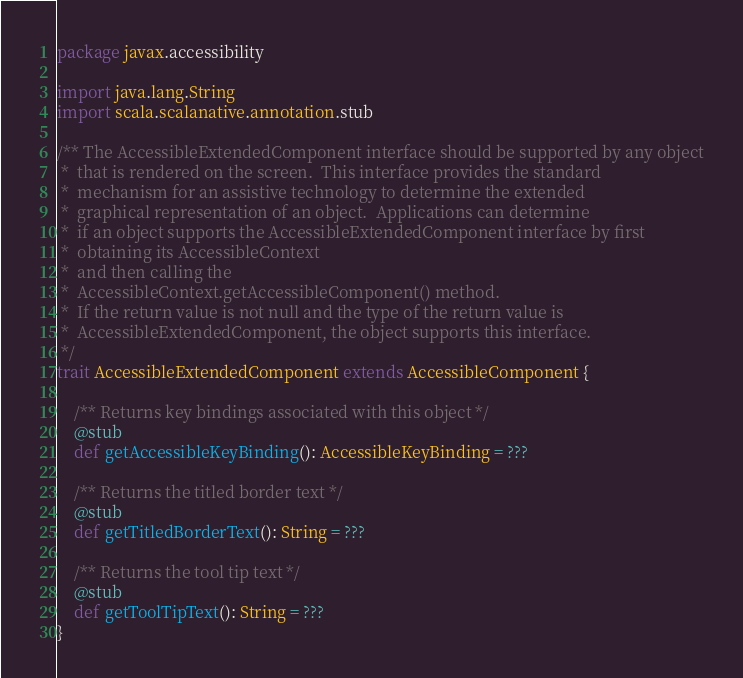<code> <loc_0><loc_0><loc_500><loc_500><_Scala_>package javax.accessibility

import java.lang.String
import scala.scalanative.annotation.stub

/** The AccessibleExtendedComponent interface should be supported by any object
 *  that is rendered on the screen.  This interface provides the standard
 *  mechanism for an assistive technology to determine the extended
 *  graphical representation of an object.  Applications can determine
 *  if an object supports the AccessibleExtendedComponent interface by first
 *  obtaining its AccessibleContext
 *  and then calling the
 *  AccessibleContext.getAccessibleComponent() method.
 *  If the return value is not null and the type of the return value is
 *  AccessibleExtendedComponent, the object supports this interface.
 */
trait AccessibleExtendedComponent extends AccessibleComponent {

    /** Returns key bindings associated with this object */
    @stub
    def getAccessibleKeyBinding(): AccessibleKeyBinding = ???

    /** Returns the titled border text */
    @stub
    def getTitledBorderText(): String = ???

    /** Returns the tool tip text */
    @stub
    def getToolTipText(): String = ???
}
</code> 